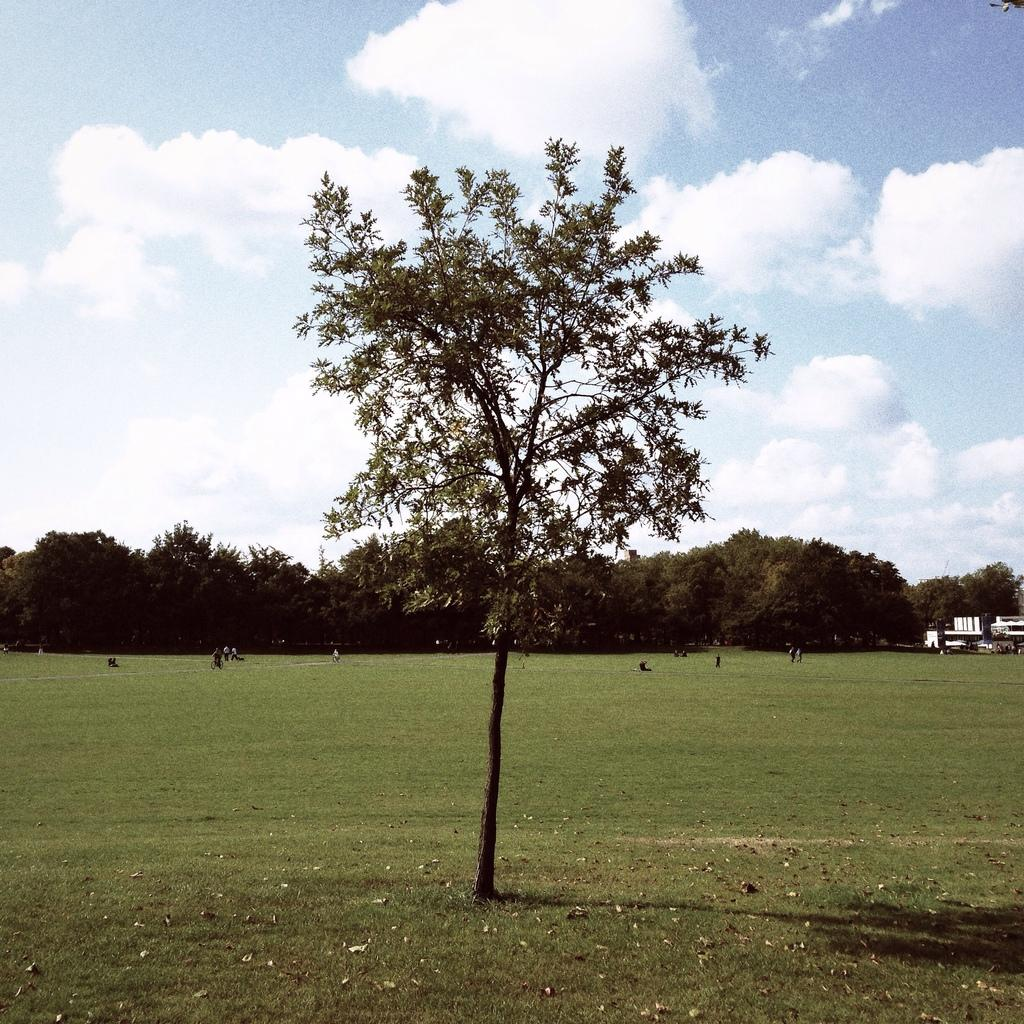What can be seen at the bottom of the image? The ground is visible in the image. What type of natural elements are in the background of the image? There are trees in the background of the image. What type of man-made structures are in the background of the image? There are buildings in the background of the image. What is visible in the sky in the background of the image? The sky is visible in the background of the image, and clouds are present. Can you see any goldfish swimming in the sky in the image? There are no goldfish present in the image, and they cannot swim in the sky. What type of wool is being used to create the clouds in the image? There is no wool present in the image, and the clouds are natural formations in the sky. 